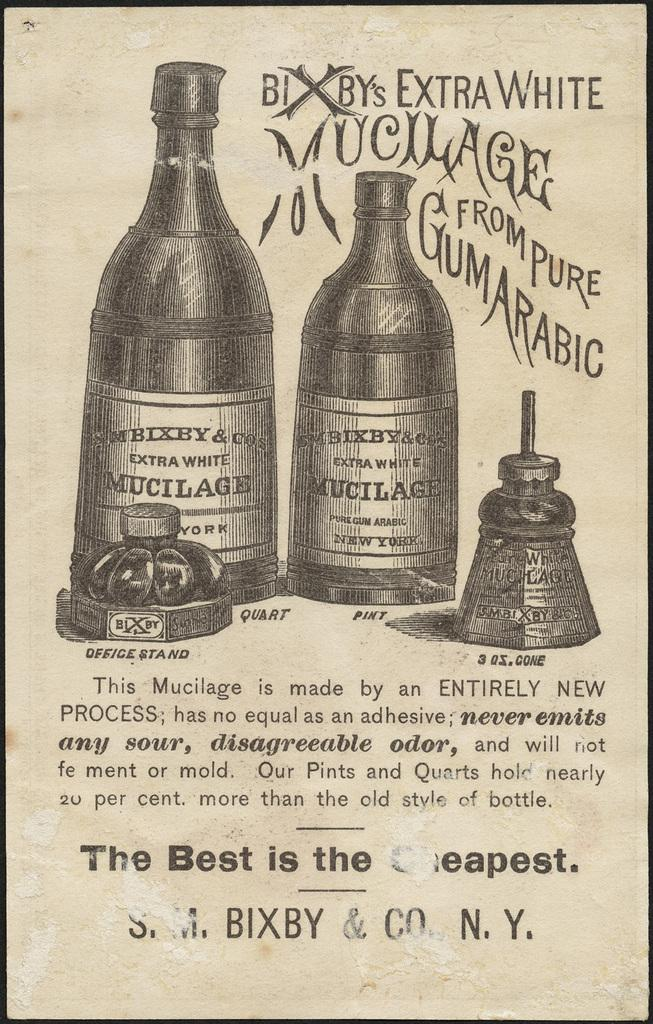<image>
Share a concise interpretation of the image provided. Drawing of beer for Bixby's Extra White from Pure Gum Arabic. 